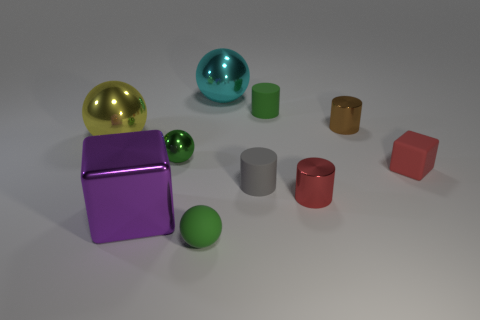Is the number of green matte cylinders less than the number of large green rubber cubes?
Your answer should be compact. No. There is a green object that is in front of the block on the left side of the red matte cube; are there any large cubes right of it?
Your answer should be very brief. No. How many rubber objects are big blue cubes or cyan spheres?
Provide a succinct answer. 0. Do the matte sphere and the small metal sphere have the same color?
Provide a succinct answer. Yes. There is a big cyan ball; what number of small green rubber objects are left of it?
Your response must be concise. 1. What number of big shiny objects are both left of the tiny shiny ball and right of the yellow shiny object?
Offer a terse response. 1. What shape is the small brown thing that is the same material as the tiny red cylinder?
Ensure brevity in your answer.  Cylinder. Does the ball that is behind the brown cylinder have the same size as the block to the left of the brown object?
Offer a terse response. Yes. What is the color of the small shiny cylinder in front of the gray cylinder?
Your answer should be compact. Red. What is the material of the tiny cylinder right of the tiny metal cylinder that is in front of the tiny green shiny sphere?
Provide a succinct answer. Metal. 